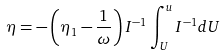Convert formula to latex. <formula><loc_0><loc_0><loc_500><loc_500>\eta = - \left ( \eta _ { 1 } - \frac { 1 } { \omega } \right ) I ^ { - 1 } \int ^ { u } _ { U } I ^ { - 1 } d U</formula> 